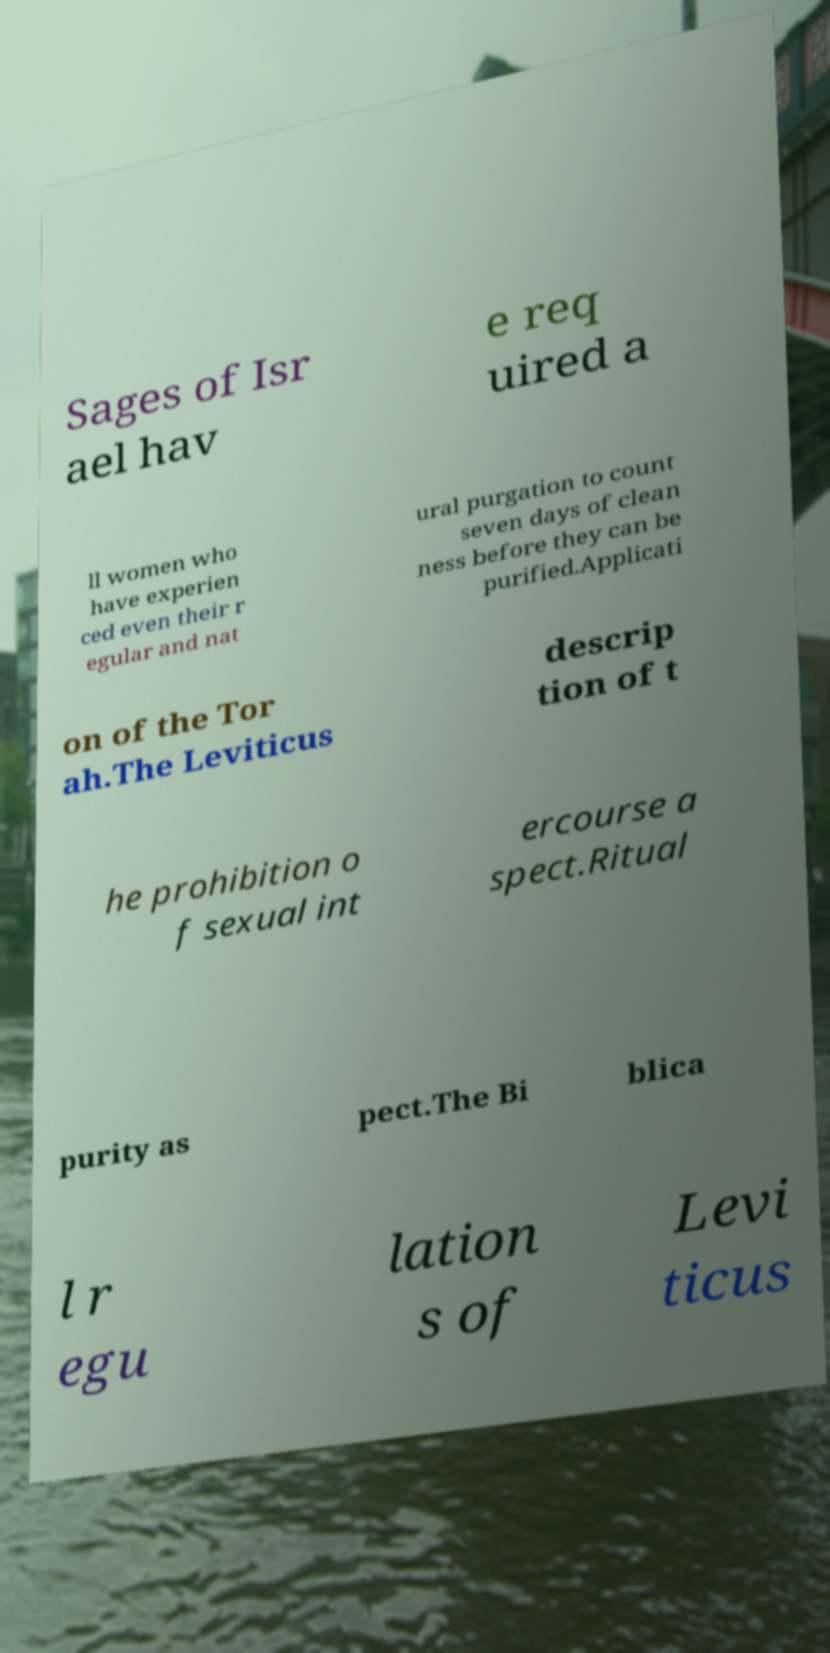I need the written content from this picture converted into text. Can you do that? Sages of Isr ael hav e req uired a ll women who have experien ced even their r egular and nat ural purgation to count seven days of clean ness before they can be purified.Applicati on of the Tor ah.The Leviticus descrip tion of t he prohibition o f sexual int ercourse a spect.Ritual purity as pect.The Bi blica l r egu lation s of Levi ticus 